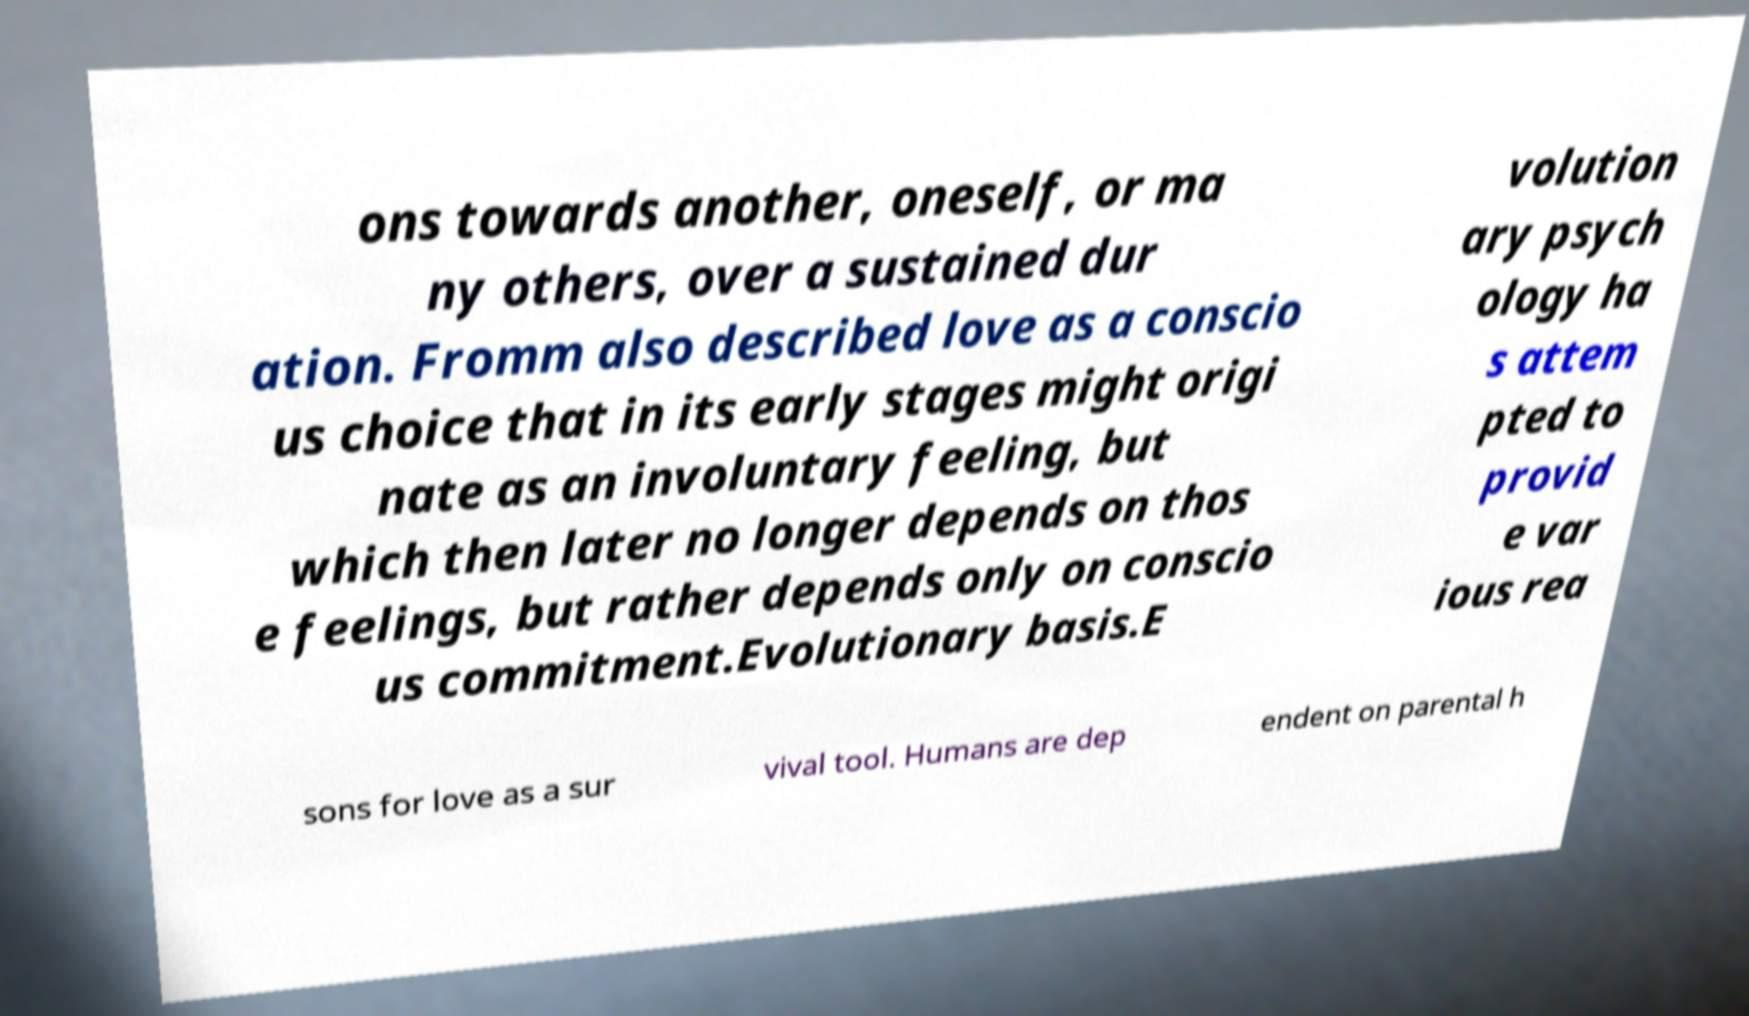I need the written content from this picture converted into text. Can you do that? ons towards another, oneself, or ma ny others, over a sustained dur ation. Fromm also described love as a conscio us choice that in its early stages might origi nate as an involuntary feeling, but which then later no longer depends on thos e feelings, but rather depends only on conscio us commitment.Evolutionary basis.E volution ary psych ology ha s attem pted to provid e var ious rea sons for love as a sur vival tool. Humans are dep endent on parental h 